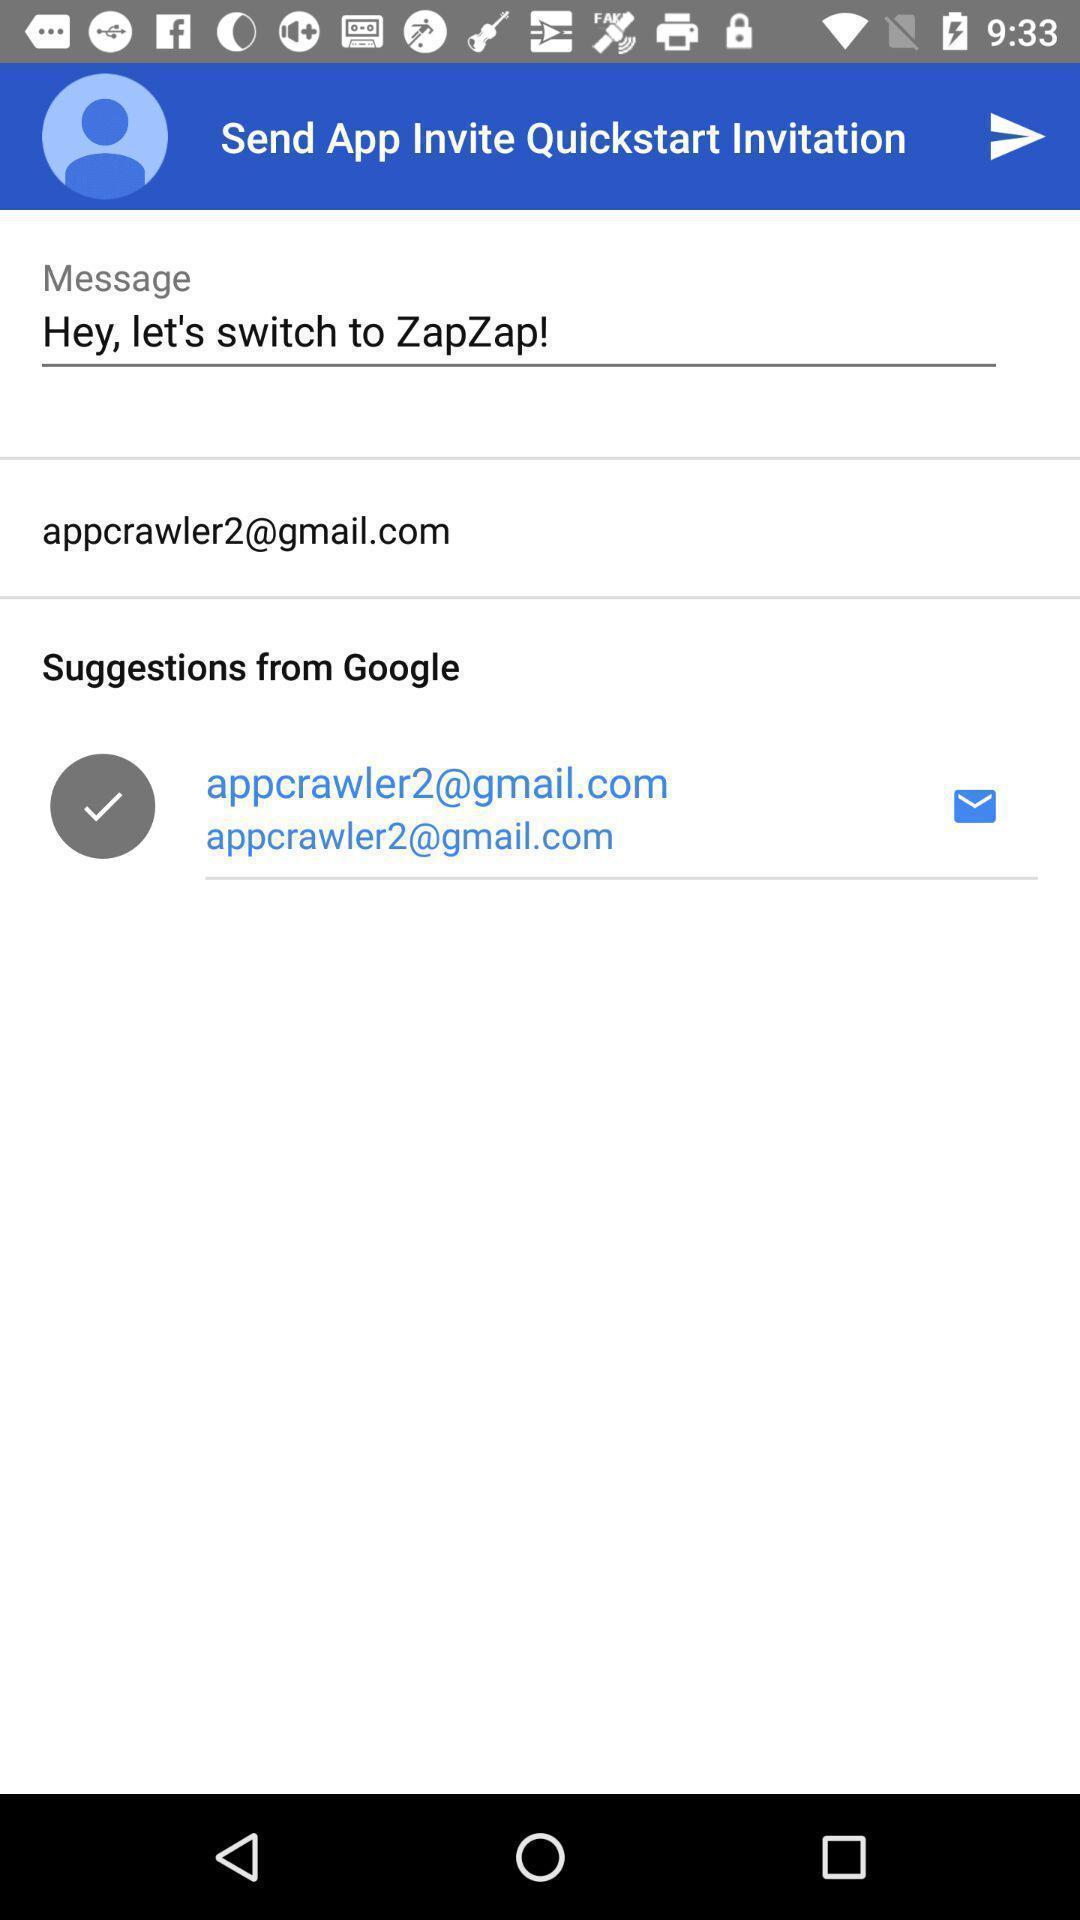Explain what's happening in this screen capture. Screen showing send app invite. 